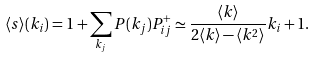Convert formula to latex. <formula><loc_0><loc_0><loc_500><loc_500>\langle s \rangle ( k _ { i } ) = 1 + \sum _ { k _ { j } } P ( k _ { j } ) P _ { i j } ^ { + } \simeq \frac { \langle k \rangle } { 2 \langle k \rangle - \langle k ^ { 2 } \rangle } k _ { i } + 1 .</formula> 